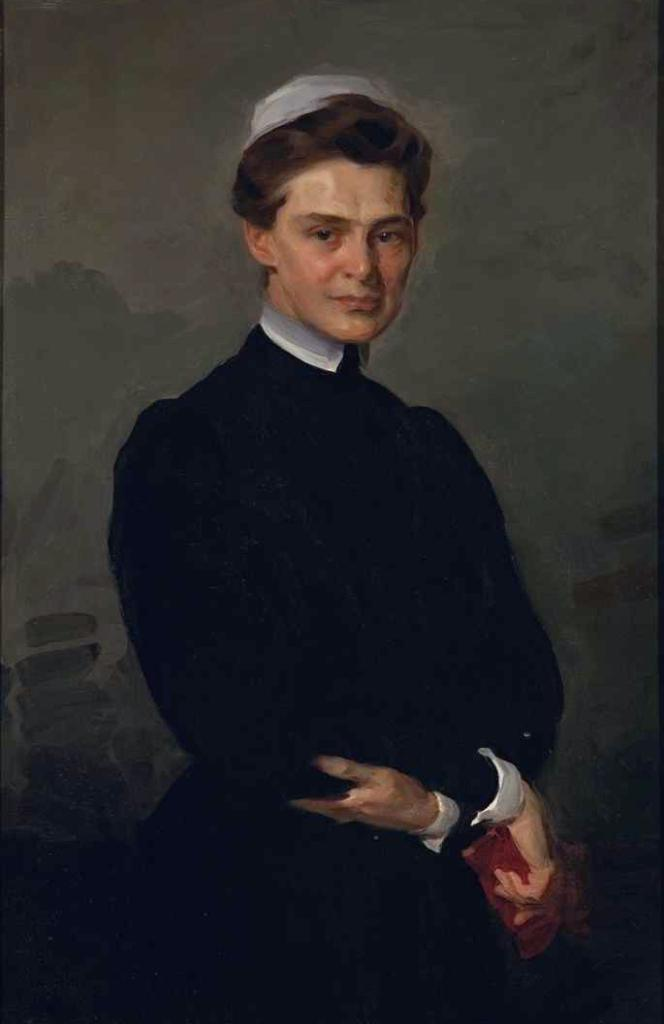What type of artwork is depicted in the image? The image is a painting. What is the main subject of the painting? There is a lady standing in the painting. What is the lady wearing in the painting? The lady is wearing a black dress. What can be seen in the background of the painting? There is a wall in the background of the painting. What type of coil is used to create the magic in the painting? There is no coil or magic present in the painting; it is a realistic depiction of a lady standing in front of a wall. 